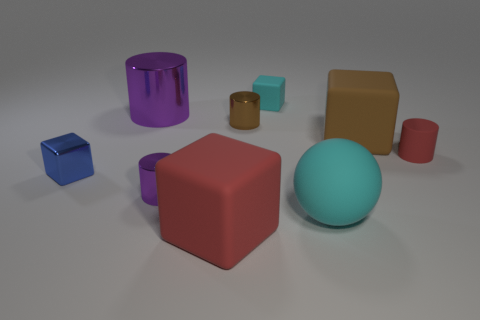What number of other things are there of the same shape as the large cyan object?
Provide a succinct answer. 0. There is a tiny rubber object in front of the cyan rubber object that is to the left of the cyan matte object that is in front of the small purple cylinder; what color is it?
Make the answer very short. Red. What number of large blue matte cylinders are there?
Your answer should be compact. 0. How many large objects are either red cylinders or purple metallic things?
Your response must be concise. 1. What shape is the metal object that is the same size as the red matte cube?
Your answer should be very brief. Cylinder. Is there any other thing that has the same size as the shiny block?
Offer a very short reply. Yes. There is a purple thing behind the large thing on the right side of the large cyan thing; what is its material?
Your answer should be very brief. Metal. Is the brown metal cylinder the same size as the blue object?
Offer a terse response. Yes. How many objects are tiny rubber objects in front of the brown cylinder or large metal objects?
Keep it short and to the point. 2. What is the shape of the big matte object on the left side of the cyan rubber thing that is on the left side of the rubber sphere?
Your response must be concise. Cube. 